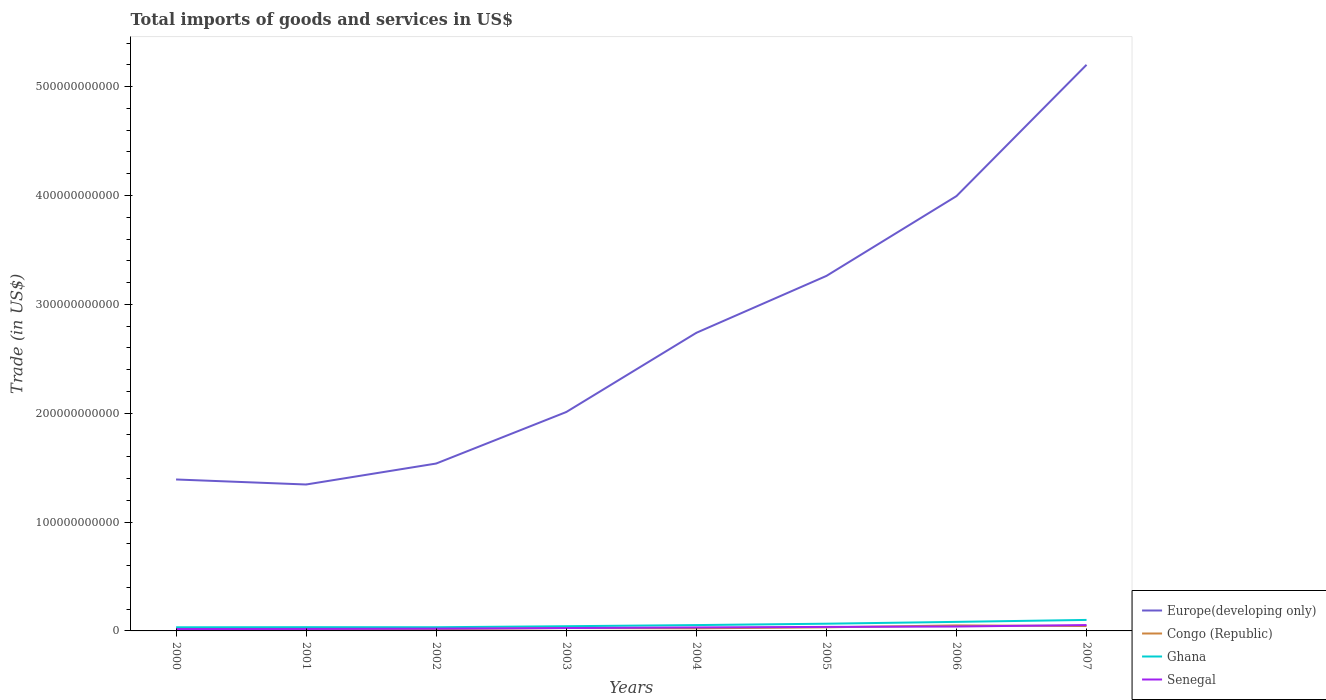Does the line corresponding to Europe(developing only) intersect with the line corresponding to Ghana?
Make the answer very short. No. Across all years, what is the maximum total imports of goods and services in Congo (Republic)?
Make the answer very short. 1.40e+09. In which year was the total imports of goods and services in Congo (Republic) maximum?
Offer a terse response. 2000. What is the total total imports of goods and services in Congo (Republic) in the graph?
Offer a very short reply. -2.41e+09. What is the difference between the highest and the second highest total imports of goods and services in Ghana?
Make the answer very short. 6.76e+09. What is the difference between the highest and the lowest total imports of goods and services in Europe(developing only)?
Offer a very short reply. 4. How many lines are there?
Ensure brevity in your answer.  4. What is the difference between two consecutive major ticks on the Y-axis?
Your response must be concise. 1.00e+11. Does the graph contain grids?
Make the answer very short. No. Where does the legend appear in the graph?
Offer a terse response. Bottom right. How are the legend labels stacked?
Give a very brief answer. Vertical. What is the title of the graph?
Provide a succinct answer. Total imports of goods and services in US$. Does "South Sudan" appear as one of the legend labels in the graph?
Make the answer very short. No. What is the label or title of the Y-axis?
Offer a very short reply. Trade (in US$). What is the Trade (in US$) in Europe(developing only) in 2000?
Offer a very short reply. 1.39e+11. What is the Trade (in US$) in Congo (Republic) in 2000?
Your answer should be compact. 1.40e+09. What is the Trade (in US$) in Ghana in 2000?
Provide a short and direct response. 3.35e+09. What is the Trade (in US$) in Senegal in 2000?
Offer a very short reply. 1.74e+09. What is the Trade (in US$) of Europe(developing only) in 2001?
Your response must be concise. 1.35e+11. What is the Trade (in US$) of Congo (Republic) in 2001?
Offer a terse response. 1.49e+09. What is the Trade (in US$) of Ghana in 2001?
Provide a succinct answer. 3.44e+09. What is the Trade (in US$) of Senegal in 2001?
Give a very brief answer. 1.84e+09. What is the Trade (in US$) of Europe(developing only) in 2002?
Offer a terse response. 1.54e+11. What is the Trade (in US$) in Congo (Republic) in 2002?
Offer a very short reply. 1.63e+09. What is the Trade (in US$) in Ghana in 2002?
Offer a very short reply. 3.38e+09. What is the Trade (in US$) of Senegal in 2002?
Ensure brevity in your answer.  2.08e+09. What is the Trade (in US$) of Europe(developing only) in 2003?
Your answer should be compact. 2.01e+11. What is the Trade (in US$) of Congo (Republic) in 2003?
Provide a short and direct response. 2.66e+09. What is the Trade (in US$) in Ghana in 2003?
Make the answer very short. 4.32e+09. What is the Trade (in US$) of Senegal in 2003?
Keep it short and to the point. 2.66e+09. What is the Trade (in US$) in Europe(developing only) in 2004?
Keep it short and to the point. 2.74e+11. What is the Trade (in US$) in Congo (Republic) in 2004?
Ensure brevity in your answer.  2.36e+09. What is the Trade (in US$) in Ghana in 2004?
Give a very brief answer. 5.36e+09. What is the Trade (in US$) in Senegal in 2004?
Your answer should be very brief. 3.19e+09. What is the Trade (in US$) of Europe(developing only) in 2005?
Ensure brevity in your answer.  3.26e+11. What is the Trade (in US$) of Congo (Republic) in 2005?
Provide a succinct answer. 3.32e+09. What is the Trade (in US$) in Ghana in 2005?
Provide a short and direct response. 6.62e+09. What is the Trade (in US$) in Senegal in 2005?
Your response must be concise. 3.69e+09. What is the Trade (in US$) of Europe(developing only) in 2006?
Your response must be concise. 3.99e+11. What is the Trade (in US$) of Congo (Republic) in 2006?
Your response must be concise. 5.07e+09. What is the Trade (in US$) of Ghana in 2006?
Keep it short and to the point. 8.31e+09. What is the Trade (in US$) of Senegal in 2006?
Provide a succinct answer. 4.03e+09. What is the Trade (in US$) of Europe(developing only) in 2007?
Provide a succinct answer. 5.20e+11. What is the Trade (in US$) of Congo (Republic) in 2007?
Ensure brevity in your answer.  4.49e+09. What is the Trade (in US$) in Ghana in 2007?
Your answer should be very brief. 1.01e+1. What is the Trade (in US$) in Senegal in 2007?
Make the answer very short. 5.40e+09. Across all years, what is the maximum Trade (in US$) in Europe(developing only)?
Keep it short and to the point. 5.20e+11. Across all years, what is the maximum Trade (in US$) in Congo (Republic)?
Give a very brief answer. 5.07e+09. Across all years, what is the maximum Trade (in US$) of Ghana?
Give a very brief answer. 1.01e+1. Across all years, what is the maximum Trade (in US$) of Senegal?
Your answer should be compact. 5.40e+09. Across all years, what is the minimum Trade (in US$) of Europe(developing only)?
Your response must be concise. 1.35e+11. Across all years, what is the minimum Trade (in US$) in Congo (Republic)?
Make the answer very short. 1.40e+09. Across all years, what is the minimum Trade (in US$) in Ghana?
Your answer should be very brief. 3.35e+09. Across all years, what is the minimum Trade (in US$) in Senegal?
Keep it short and to the point. 1.74e+09. What is the total Trade (in US$) of Europe(developing only) in the graph?
Make the answer very short. 2.15e+12. What is the total Trade (in US$) of Congo (Republic) in the graph?
Keep it short and to the point. 2.24e+1. What is the total Trade (in US$) of Ghana in the graph?
Provide a succinct answer. 4.49e+1. What is the total Trade (in US$) in Senegal in the graph?
Your response must be concise. 2.46e+1. What is the difference between the Trade (in US$) of Europe(developing only) in 2000 and that in 2001?
Ensure brevity in your answer.  4.62e+09. What is the difference between the Trade (in US$) of Congo (Republic) in 2000 and that in 2001?
Your answer should be very brief. -8.54e+07. What is the difference between the Trade (in US$) of Ghana in 2000 and that in 2001?
Ensure brevity in your answer.  -9.39e+07. What is the difference between the Trade (in US$) in Senegal in 2000 and that in 2001?
Your response must be concise. -1.00e+08. What is the difference between the Trade (in US$) in Europe(developing only) in 2000 and that in 2002?
Offer a very short reply. -1.47e+1. What is the difference between the Trade (in US$) in Congo (Republic) in 2000 and that in 2002?
Make the answer very short. -2.25e+08. What is the difference between the Trade (in US$) in Ghana in 2000 and that in 2002?
Your answer should be compact. -3.28e+07. What is the difference between the Trade (in US$) of Senegal in 2000 and that in 2002?
Give a very brief answer. -3.37e+08. What is the difference between the Trade (in US$) of Europe(developing only) in 2000 and that in 2003?
Keep it short and to the point. -6.20e+1. What is the difference between the Trade (in US$) of Congo (Republic) in 2000 and that in 2003?
Your response must be concise. -1.25e+09. What is the difference between the Trade (in US$) of Ghana in 2000 and that in 2003?
Make the answer very short. -9.70e+08. What is the difference between the Trade (in US$) of Senegal in 2000 and that in 2003?
Offer a very short reply. -9.15e+08. What is the difference between the Trade (in US$) of Europe(developing only) in 2000 and that in 2004?
Ensure brevity in your answer.  -1.35e+11. What is the difference between the Trade (in US$) of Congo (Republic) in 2000 and that in 2004?
Your response must be concise. -9.59e+08. What is the difference between the Trade (in US$) in Ghana in 2000 and that in 2004?
Provide a short and direct response. -2.01e+09. What is the difference between the Trade (in US$) in Senegal in 2000 and that in 2004?
Your answer should be very brief. -1.45e+09. What is the difference between the Trade (in US$) in Europe(developing only) in 2000 and that in 2005?
Your response must be concise. -1.87e+11. What is the difference between the Trade (in US$) of Congo (Republic) in 2000 and that in 2005?
Give a very brief answer. -1.91e+09. What is the difference between the Trade (in US$) of Ghana in 2000 and that in 2005?
Provide a succinct answer. -3.27e+09. What is the difference between the Trade (in US$) in Senegal in 2000 and that in 2005?
Provide a short and direct response. -1.95e+09. What is the difference between the Trade (in US$) in Europe(developing only) in 2000 and that in 2006?
Provide a short and direct response. -2.60e+11. What is the difference between the Trade (in US$) in Congo (Republic) in 2000 and that in 2006?
Keep it short and to the point. -3.67e+09. What is the difference between the Trade (in US$) in Ghana in 2000 and that in 2006?
Offer a very short reply. -4.96e+09. What is the difference between the Trade (in US$) in Senegal in 2000 and that in 2006?
Make the answer very short. -2.29e+09. What is the difference between the Trade (in US$) of Europe(developing only) in 2000 and that in 2007?
Give a very brief answer. -3.81e+11. What is the difference between the Trade (in US$) of Congo (Republic) in 2000 and that in 2007?
Give a very brief answer. -3.09e+09. What is the difference between the Trade (in US$) in Ghana in 2000 and that in 2007?
Keep it short and to the point. -6.76e+09. What is the difference between the Trade (in US$) of Senegal in 2000 and that in 2007?
Give a very brief answer. -3.66e+09. What is the difference between the Trade (in US$) in Europe(developing only) in 2001 and that in 2002?
Offer a terse response. -1.93e+1. What is the difference between the Trade (in US$) of Congo (Republic) in 2001 and that in 2002?
Your answer should be compact. -1.39e+08. What is the difference between the Trade (in US$) of Ghana in 2001 and that in 2002?
Your answer should be very brief. 6.11e+07. What is the difference between the Trade (in US$) in Senegal in 2001 and that in 2002?
Keep it short and to the point. -2.36e+08. What is the difference between the Trade (in US$) in Europe(developing only) in 2001 and that in 2003?
Your answer should be compact. -6.66e+1. What is the difference between the Trade (in US$) in Congo (Republic) in 2001 and that in 2003?
Keep it short and to the point. -1.17e+09. What is the difference between the Trade (in US$) in Ghana in 2001 and that in 2003?
Your answer should be very brief. -8.76e+08. What is the difference between the Trade (in US$) in Senegal in 2001 and that in 2003?
Provide a succinct answer. -8.15e+08. What is the difference between the Trade (in US$) of Europe(developing only) in 2001 and that in 2004?
Make the answer very short. -1.39e+11. What is the difference between the Trade (in US$) of Congo (Republic) in 2001 and that in 2004?
Offer a terse response. -8.74e+08. What is the difference between the Trade (in US$) of Ghana in 2001 and that in 2004?
Give a very brief answer. -1.92e+09. What is the difference between the Trade (in US$) in Senegal in 2001 and that in 2004?
Make the answer very short. -1.35e+09. What is the difference between the Trade (in US$) of Europe(developing only) in 2001 and that in 2005?
Give a very brief answer. -1.92e+11. What is the difference between the Trade (in US$) of Congo (Republic) in 2001 and that in 2005?
Provide a short and direct response. -1.83e+09. What is the difference between the Trade (in US$) in Ghana in 2001 and that in 2005?
Provide a short and direct response. -3.18e+09. What is the difference between the Trade (in US$) of Senegal in 2001 and that in 2005?
Make the answer very short. -1.85e+09. What is the difference between the Trade (in US$) in Europe(developing only) in 2001 and that in 2006?
Keep it short and to the point. -2.65e+11. What is the difference between the Trade (in US$) in Congo (Republic) in 2001 and that in 2006?
Give a very brief answer. -3.58e+09. What is the difference between the Trade (in US$) in Ghana in 2001 and that in 2006?
Provide a succinct answer. -4.87e+09. What is the difference between the Trade (in US$) of Senegal in 2001 and that in 2006?
Ensure brevity in your answer.  -2.19e+09. What is the difference between the Trade (in US$) of Europe(developing only) in 2001 and that in 2007?
Ensure brevity in your answer.  -3.86e+11. What is the difference between the Trade (in US$) of Congo (Republic) in 2001 and that in 2007?
Offer a very short reply. -3.00e+09. What is the difference between the Trade (in US$) in Ghana in 2001 and that in 2007?
Your answer should be very brief. -6.66e+09. What is the difference between the Trade (in US$) in Senegal in 2001 and that in 2007?
Give a very brief answer. -3.56e+09. What is the difference between the Trade (in US$) of Europe(developing only) in 2002 and that in 2003?
Keep it short and to the point. -4.73e+1. What is the difference between the Trade (in US$) in Congo (Republic) in 2002 and that in 2003?
Your response must be concise. -1.03e+09. What is the difference between the Trade (in US$) in Ghana in 2002 and that in 2003?
Offer a very short reply. -9.37e+08. What is the difference between the Trade (in US$) in Senegal in 2002 and that in 2003?
Ensure brevity in your answer.  -5.79e+08. What is the difference between the Trade (in US$) of Europe(developing only) in 2002 and that in 2004?
Provide a short and direct response. -1.20e+11. What is the difference between the Trade (in US$) in Congo (Republic) in 2002 and that in 2004?
Your answer should be very brief. -7.34e+08. What is the difference between the Trade (in US$) in Ghana in 2002 and that in 2004?
Your answer should be compact. -1.98e+09. What is the difference between the Trade (in US$) in Senegal in 2002 and that in 2004?
Provide a succinct answer. -1.12e+09. What is the difference between the Trade (in US$) in Europe(developing only) in 2002 and that in 2005?
Offer a terse response. -1.72e+11. What is the difference between the Trade (in US$) of Congo (Republic) in 2002 and that in 2005?
Make the answer very short. -1.69e+09. What is the difference between the Trade (in US$) in Ghana in 2002 and that in 2005?
Give a very brief answer. -3.24e+09. What is the difference between the Trade (in US$) in Senegal in 2002 and that in 2005?
Your response must be concise. -1.62e+09. What is the difference between the Trade (in US$) of Europe(developing only) in 2002 and that in 2006?
Keep it short and to the point. -2.46e+11. What is the difference between the Trade (in US$) of Congo (Republic) in 2002 and that in 2006?
Offer a very short reply. -3.44e+09. What is the difference between the Trade (in US$) of Ghana in 2002 and that in 2006?
Make the answer very short. -4.93e+09. What is the difference between the Trade (in US$) in Senegal in 2002 and that in 2006?
Your response must be concise. -1.96e+09. What is the difference between the Trade (in US$) in Europe(developing only) in 2002 and that in 2007?
Keep it short and to the point. -3.66e+11. What is the difference between the Trade (in US$) of Congo (Republic) in 2002 and that in 2007?
Provide a short and direct response. -2.86e+09. What is the difference between the Trade (in US$) of Ghana in 2002 and that in 2007?
Make the answer very short. -6.73e+09. What is the difference between the Trade (in US$) of Senegal in 2002 and that in 2007?
Keep it short and to the point. -3.32e+09. What is the difference between the Trade (in US$) of Europe(developing only) in 2003 and that in 2004?
Your answer should be very brief. -7.28e+1. What is the difference between the Trade (in US$) of Congo (Republic) in 2003 and that in 2004?
Keep it short and to the point. 2.95e+08. What is the difference between the Trade (in US$) of Ghana in 2003 and that in 2004?
Ensure brevity in your answer.  -1.04e+09. What is the difference between the Trade (in US$) in Senegal in 2003 and that in 2004?
Ensure brevity in your answer.  -5.37e+08. What is the difference between the Trade (in US$) of Europe(developing only) in 2003 and that in 2005?
Give a very brief answer. -1.25e+11. What is the difference between the Trade (in US$) in Congo (Republic) in 2003 and that in 2005?
Provide a succinct answer. -6.59e+08. What is the difference between the Trade (in US$) of Ghana in 2003 and that in 2005?
Ensure brevity in your answer.  -2.30e+09. What is the difference between the Trade (in US$) in Senegal in 2003 and that in 2005?
Provide a succinct answer. -1.04e+09. What is the difference between the Trade (in US$) in Europe(developing only) in 2003 and that in 2006?
Give a very brief answer. -1.98e+11. What is the difference between the Trade (in US$) in Congo (Republic) in 2003 and that in 2006?
Offer a very short reply. -2.41e+09. What is the difference between the Trade (in US$) of Ghana in 2003 and that in 2006?
Keep it short and to the point. -3.99e+09. What is the difference between the Trade (in US$) in Senegal in 2003 and that in 2006?
Provide a succinct answer. -1.38e+09. What is the difference between the Trade (in US$) in Europe(developing only) in 2003 and that in 2007?
Ensure brevity in your answer.  -3.19e+11. What is the difference between the Trade (in US$) in Congo (Republic) in 2003 and that in 2007?
Your answer should be very brief. -1.83e+09. What is the difference between the Trade (in US$) of Ghana in 2003 and that in 2007?
Keep it short and to the point. -5.79e+09. What is the difference between the Trade (in US$) of Senegal in 2003 and that in 2007?
Your response must be concise. -2.74e+09. What is the difference between the Trade (in US$) of Europe(developing only) in 2004 and that in 2005?
Offer a terse response. -5.23e+1. What is the difference between the Trade (in US$) in Congo (Republic) in 2004 and that in 2005?
Provide a short and direct response. -9.54e+08. What is the difference between the Trade (in US$) in Ghana in 2004 and that in 2005?
Provide a short and direct response. -1.26e+09. What is the difference between the Trade (in US$) of Senegal in 2004 and that in 2005?
Your answer should be compact. -5.00e+08. What is the difference between the Trade (in US$) in Europe(developing only) in 2004 and that in 2006?
Give a very brief answer. -1.26e+11. What is the difference between the Trade (in US$) of Congo (Republic) in 2004 and that in 2006?
Your answer should be compact. -2.71e+09. What is the difference between the Trade (in US$) of Ghana in 2004 and that in 2006?
Your response must be concise. -2.95e+09. What is the difference between the Trade (in US$) in Senegal in 2004 and that in 2006?
Your response must be concise. -8.39e+08. What is the difference between the Trade (in US$) in Europe(developing only) in 2004 and that in 2007?
Keep it short and to the point. -2.46e+11. What is the difference between the Trade (in US$) in Congo (Republic) in 2004 and that in 2007?
Give a very brief answer. -2.13e+09. What is the difference between the Trade (in US$) of Ghana in 2004 and that in 2007?
Give a very brief answer. -4.75e+09. What is the difference between the Trade (in US$) of Senegal in 2004 and that in 2007?
Make the answer very short. -2.21e+09. What is the difference between the Trade (in US$) of Europe(developing only) in 2005 and that in 2006?
Provide a short and direct response. -7.33e+1. What is the difference between the Trade (in US$) of Congo (Republic) in 2005 and that in 2006?
Offer a very short reply. -1.76e+09. What is the difference between the Trade (in US$) of Ghana in 2005 and that in 2006?
Keep it short and to the point. -1.69e+09. What is the difference between the Trade (in US$) in Senegal in 2005 and that in 2006?
Keep it short and to the point. -3.39e+08. What is the difference between the Trade (in US$) of Europe(developing only) in 2005 and that in 2007?
Provide a succinct answer. -1.94e+11. What is the difference between the Trade (in US$) of Congo (Republic) in 2005 and that in 2007?
Offer a terse response. -1.18e+09. What is the difference between the Trade (in US$) of Ghana in 2005 and that in 2007?
Offer a terse response. -3.49e+09. What is the difference between the Trade (in US$) of Senegal in 2005 and that in 2007?
Your answer should be very brief. -1.71e+09. What is the difference between the Trade (in US$) in Europe(developing only) in 2006 and that in 2007?
Give a very brief answer. -1.21e+11. What is the difference between the Trade (in US$) in Congo (Republic) in 2006 and that in 2007?
Offer a very short reply. 5.80e+08. What is the difference between the Trade (in US$) in Ghana in 2006 and that in 2007?
Ensure brevity in your answer.  -1.80e+09. What is the difference between the Trade (in US$) of Senegal in 2006 and that in 2007?
Ensure brevity in your answer.  -1.37e+09. What is the difference between the Trade (in US$) in Europe(developing only) in 2000 and the Trade (in US$) in Congo (Republic) in 2001?
Offer a terse response. 1.38e+11. What is the difference between the Trade (in US$) of Europe(developing only) in 2000 and the Trade (in US$) of Ghana in 2001?
Offer a terse response. 1.36e+11. What is the difference between the Trade (in US$) in Europe(developing only) in 2000 and the Trade (in US$) in Senegal in 2001?
Your answer should be compact. 1.37e+11. What is the difference between the Trade (in US$) in Congo (Republic) in 2000 and the Trade (in US$) in Ghana in 2001?
Offer a very short reply. -2.04e+09. What is the difference between the Trade (in US$) of Congo (Republic) in 2000 and the Trade (in US$) of Senegal in 2001?
Offer a very short reply. -4.38e+08. What is the difference between the Trade (in US$) of Ghana in 2000 and the Trade (in US$) of Senegal in 2001?
Make the answer very short. 1.51e+09. What is the difference between the Trade (in US$) of Europe(developing only) in 2000 and the Trade (in US$) of Congo (Republic) in 2002?
Your response must be concise. 1.37e+11. What is the difference between the Trade (in US$) in Europe(developing only) in 2000 and the Trade (in US$) in Ghana in 2002?
Your answer should be very brief. 1.36e+11. What is the difference between the Trade (in US$) in Europe(developing only) in 2000 and the Trade (in US$) in Senegal in 2002?
Keep it short and to the point. 1.37e+11. What is the difference between the Trade (in US$) of Congo (Republic) in 2000 and the Trade (in US$) of Ghana in 2002?
Keep it short and to the point. -1.98e+09. What is the difference between the Trade (in US$) of Congo (Republic) in 2000 and the Trade (in US$) of Senegal in 2002?
Provide a short and direct response. -6.74e+08. What is the difference between the Trade (in US$) in Ghana in 2000 and the Trade (in US$) in Senegal in 2002?
Provide a succinct answer. 1.27e+09. What is the difference between the Trade (in US$) of Europe(developing only) in 2000 and the Trade (in US$) of Congo (Republic) in 2003?
Keep it short and to the point. 1.36e+11. What is the difference between the Trade (in US$) in Europe(developing only) in 2000 and the Trade (in US$) in Ghana in 2003?
Make the answer very short. 1.35e+11. What is the difference between the Trade (in US$) of Europe(developing only) in 2000 and the Trade (in US$) of Senegal in 2003?
Offer a very short reply. 1.36e+11. What is the difference between the Trade (in US$) in Congo (Republic) in 2000 and the Trade (in US$) in Ghana in 2003?
Provide a short and direct response. -2.92e+09. What is the difference between the Trade (in US$) of Congo (Republic) in 2000 and the Trade (in US$) of Senegal in 2003?
Keep it short and to the point. -1.25e+09. What is the difference between the Trade (in US$) of Ghana in 2000 and the Trade (in US$) of Senegal in 2003?
Give a very brief answer. 6.94e+08. What is the difference between the Trade (in US$) of Europe(developing only) in 2000 and the Trade (in US$) of Congo (Republic) in 2004?
Your response must be concise. 1.37e+11. What is the difference between the Trade (in US$) of Europe(developing only) in 2000 and the Trade (in US$) of Ghana in 2004?
Offer a very short reply. 1.34e+11. What is the difference between the Trade (in US$) in Europe(developing only) in 2000 and the Trade (in US$) in Senegal in 2004?
Provide a short and direct response. 1.36e+11. What is the difference between the Trade (in US$) in Congo (Republic) in 2000 and the Trade (in US$) in Ghana in 2004?
Ensure brevity in your answer.  -3.96e+09. What is the difference between the Trade (in US$) of Congo (Republic) in 2000 and the Trade (in US$) of Senegal in 2004?
Provide a short and direct response. -1.79e+09. What is the difference between the Trade (in US$) of Ghana in 2000 and the Trade (in US$) of Senegal in 2004?
Your answer should be very brief. 1.57e+08. What is the difference between the Trade (in US$) of Europe(developing only) in 2000 and the Trade (in US$) of Congo (Republic) in 2005?
Provide a short and direct response. 1.36e+11. What is the difference between the Trade (in US$) in Europe(developing only) in 2000 and the Trade (in US$) in Ghana in 2005?
Your response must be concise. 1.32e+11. What is the difference between the Trade (in US$) in Europe(developing only) in 2000 and the Trade (in US$) in Senegal in 2005?
Your answer should be compact. 1.35e+11. What is the difference between the Trade (in US$) in Congo (Republic) in 2000 and the Trade (in US$) in Ghana in 2005?
Keep it short and to the point. -5.22e+09. What is the difference between the Trade (in US$) of Congo (Republic) in 2000 and the Trade (in US$) of Senegal in 2005?
Ensure brevity in your answer.  -2.29e+09. What is the difference between the Trade (in US$) in Ghana in 2000 and the Trade (in US$) in Senegal in 2005?
Your answer should be compact. -3.43e+08. What is the difference between the Trade (in US$) of Europe(developing only) in 2000 and the Trade (in US$) of Congo (Republic) in 2006?
Keep it short and to the point. 1.34e+11. What is the difference between the Trade (in US$) of Europe(developing only) in 2000 and the Trade (in US$) of Ghana in 2006?
Ensure brevity in your answer.  1.31e+11. What is the difference between the Trade (in US$) in Europe(developing only) in 2000 and the Trade (in US$) in Senegal in 2006?
Provide a succinct answer. 1.35e+11. What is the difference between the Trade (in US$) of Congo (Republic) in 2000 and the Trade (in US$) of Ghana in 2006?
Offer a terse response. -6.91e+09. What is the difference between the Trade (in US$) in Congo (Republic) in 2000 and the Trade (in US$) in Senegal in 2006?
Your answer should be compact. -2.63e+09. What is the difference between the Trade (in US$) in Ghana in 2000 and the Trade (in US$) in Senegal in 2006?
Your answer should be compact. -6.82e+08. What is the difference between the Trade (in US$) of Europe(developing only) in 2000 and the Trade (in US$) of Congo (Republic) in 2007?
Offer a terse response. 1.35e+11. What is the difference between the Trade (in US$) in Europe(developing only) in 2000 and the Trade (in US$) in Ghana in 2007?
Ensure brevity in your answer.  1.29e+11. What is the difference between the Trade (in US$) in Europe(developing only) in 2000 and the Trade (in US$) in Senegal in 2007?
Provide a short and direct response. 1.34e+11. What is the difference between the Trade (in US$) in Congo (Republic) in 2000 and the Trade (in US$) in Ghana in 2007?
Provide a succinct answer. -8.70e+09. What is the difference between the Trade (in US$) of Congo (Republic) in 2000 and the Trade (in US$) of Senegal in 2007?
Offer a very short reply. -3.99e+09. What is the difference between the Trade (in US$) in Ghana in 2000 and the Trade (in US$) in Senegal in 2007?
Your answer should be very brief. -2.05e+09. What is the difference between the Trade (in US$) in Europe(developing only) in 2001 and the Trade (in US$) in Congo (Republic) in 2002?
Your answer should be compact. 1.33e+11. What is the difference between the Trade (in US$) of Europe(developing only) in 2001 and the Trade (in US$) of Ghana in 2002?
Make the answer very short. 1.31e+11. What is the difference between the Trade (in US$) in Europe(developing only) in 2001 and the Trade (in US$) in Senegal in 2002?
Give a very brief answer. 1.32e+11. What is the difference between the Trade (in US$) of Congo (Republic) in 2001 and the Trade (in US$) of Ghana in 2002?
Your answer should be very brief. -1.89e+09. What is the difference between the Trade (in US$) in Congo (Republic) in 2001 and the Trade (in US$) in Senegal in 2002?
Offer a terse response. -5.89e+08. What is the difference between the Trade (in US$) of Ghana in 2001 and the Trade (in US$) of Senegal in 2002?
Offer a very short reply. 1.37e+09. What is the difference between the Trade (in US$) in Europe(developing only) in 2001 and the Trade (in US$) in Congo (Republic) in 2003?
Provide a succinct answer. 1.32e+11. What is the difference between the Trade (in US$) of Europe(developing only) in 2001 and the Trade (in US$) of Ghana in 2003?
Your answer should be very brief. 1.30e+11. What is the difference between the Trade (in US$) in Europe(developing only) in 2001 and the Trade (in US$) in Senegal in 2003?
Your answer should be compact. 1.32e+11. What is the difference between the Trade (in US$) in Congo (Republic) in 2001 and the Trade (in US$) in Ghana in 2003?
Your answer should be very brief. -2.83e+09. What is the difference between the Trade (in US$) in Congo (Republic) in 2001 and the Trade (in US$) in Senegal in 2003?
Provide a succinct answer. -1.17e+09. What is the difference between the Trade (in US$) in Ghana in 2001 and the Trade (in US$) in Senegal in 2003?
Give a very brief answer. 7.88e+08. What is the difference between the Trade (in US$) of Europe(developing only) in 2001 and the Trade (in US$) of Congo (Republic) in 2004?
Your answer should be compact. 1.32e+11. What is the difference between the Trade (in US$) of Europe(developing only) in 2001 and the Trade (in US$) of Ghana in 2004?
Ensure brevity in your answer.  1.29e+11. What is the difference between the Trade (in US$) in Europe(developing only) in 2001 and the Trade (in US$) in Senegal in 2004?
Make the answer very short. 1.31e+11. What is the difference between the Trade (in US$) in Congo (Republic) in 2001 and the Trade (in US$) in Ghana in 2004?
Ensure brevity in your answer.  -3.87e+09. What is the difference between the Trade (in US$) of Congo (Republic) in 2001 and the Trade (in US$) of Senegal in 2004?
Give a very brief answer. -1.70e+09. What is the difference between the Trade (in US$) of Ghana in 2001 and the Trade (in US$) of Senegal in 2004?
Keep it short and to the point. 2.51e+08. What is the difference between the Trade (in US$) in Europe(developing only) in 2001 and the Trade (in US$) in Congo (Republic) in 2005?
Your answer should be very brief. 1.31e+11. What is the difference between the Trade (in US$) of Europe(developing only) in 2001 and the Trade (in US$) of Ghana in 2005?
Offer a very short reply. 1.28e+11. What is the difference between the Trade (in US$) of Europe(developing only) in 2001 and the Trade (in US$) of Senegal in 2005?
Your answer should be very brief. 1.31e+11. What is the difference between the Trade (in US$) in Congo (Republic) in 2001 and the Trade (in US$) in Ghana in 2005?
Keep it short and to the point. -5.13e+09. What is the difference between the Trade (in US$) of Congo (Republic) in 2001 and the Trade (in US$) of Senegal in 2005?
Make the answer very short. -2.20e+09. What is the difference between the Trade (in US$) in Ghana in 2001 and the Trade (in US$) in Senegal in 2005?
Offer a terse response. -2.49e+08. What is the difference between the Trade (in US$) of Europe(developing only) in 2001 and the Trade (in US$) of Congo (Republic) in 2006?
Offer a terse response. 1.29e+11. What is the difference between the Trade (in US$) of Europe(developing only) in 2001 and the Trade (in US$) of Ghana in 2006?
Offer a very short reply. 1.26e+11. What is the difference between the Trade (in US$) in Europe(developing only) in 2001 and the Trade (in US$) in Senegal in 2006?
Your answer should be compact. 1.30e+11. What is the difference between the Trade (in US$) of Congo (Republic) in 2001 and the Trade (in US$) of Ghana in 2006?
Offer a terse response. -6.82e+09. What is the difference between the Trade (in US$) of Congo (Republic) in 2001 and the Trade (in US$) of Senegal in 2006?
Offer a very short reply. -2.54e+09. What is the difference between the Trade (in US$) in Ghana in 2001 and the Trade (in US$) in Senegal in 2006?
Give a very brief answer. -5.89e+08. What is the difference between the Trade (in US$) of Europe(developing only) in 2001 and the Trade (in US$) of Congo (Republic) in 2007?
Give a very brief answer. 1.30e+11. What is the difference between the Trade (in US$) of Europe(developing only) in 2001 and the Trade (in US$) of Ghana in 2007?
Provide a succinct answer. 1.24e+11. What is the difference between the Trade (in US$) in Europe(developing only) in 2001 and the Trade (in US$) in Senegal in 2007?
Provide a short and direct response. 1.29e+11. What is the difference between the Trade (in US$) of Congo (Republic) in 2001 and the Trade (in US$) of Ghana in 2007?
Provide a short and direct response. -8.62e+09. What is the difference between the Trade (in US$) of Congo (Republic) in 2001 and the Trade (in US$) of Senegal in 2007?
Offer a very short reply. -3.91e+09. What is the difference between the Trade (in US$) of Ghana in 2001 and the Trade (in US$) of Senegal in 2007?
Provide a succinct answer. -1.95e+09. What is the difference between the Trade (in US$) in Europe(developing only) in 2002 and the Trade (in US$) in Congo (Republic) in 2003?
Provide a succinct answer. 1.51e+11. What is the difference between the Trade (in US$) of Europe(developing only) in 2002 and the Trade (in US$) of Ghana in 2003?
Your answer should be compact. 1.49e+11. What is the difference between the Trade (in US$) of Europe(developing only) in 2002 and the Trade (in US$) of Senegal in 2003?
Provide a short and direct response. 1.51e+11. What is the difference between the Trade (in US$) of Congo (Republic) in 2002 and the Trade (in US$) of Ghana in 2003?
Provide a short and direct response. -2.69e+09. What is the difference between the Trade (in US$) in Congo (Republic) in 2002 and the Trade (in US$) in Senegal in 2003?
Give a very brief answer. -1.03e+09. What is the difference between the Trade (in US$) in Ghana in 2002 and the Trade (in US$) in Senegal in 2003?
Your answer should be very brief. 7.27e+08. What is the difference between the Trade (in US$) in Europe(developing only) in 2002 and the Trade (in US$) in Congo (Republic) in 2004?
Your answer should be very brief. 1.51e+11. What is the difference between the Trade (in US$) in Europe(developing only) in 2002 and the Trade (in US$) in Ghana in 2004?
Keep it short and to the point. 1.48e+11. What is the difference between the Trade (in US$) in Europe(developing only) in 2002 and the Trade (in US$) in Senegal in 2004?
Offer a very short reply. 1.51e+11. What is the difference between the Trade (in US$) in Congo (Republic) in 2002 and the Trade (in US$) in Ghana in 2004?
Ensure brevity in your answer.  -3.73e+09. What is the difference between the Trade (in US$) of Congo (Republic) in 2002 and the Trade (in US$) of Senegal in 2004?
Offer a terse response. -1.56e+09. What is the difference between the Trade (in US$) in Ghana in 2002 and the Trade (in US$) in Senegal in 2004?
Ensure brevity in your answer.  1.90e+08. What is the difference between the Trade (in US$) in Europe(developing only) in 2002 and the Trade (in US$) in Congo (Republic) in 2005?
Keep it short and to the point. 1.50e+11. What is the difference between the Trade (in US$) in Europe(developing only) in 2002 and the Trade (in US$) in Ghana in 2005?
Offer a terse response. 1.47e+11. What is the difference between the Trade (in US$) of Europe(developing only) in 2002 and the Trade (in US$) of Senegal in 2005?
Your answer should be very brief. 1.50e+11. What is the difference between the Trade (in US$) in Congo (Republic) in 2002 and the Trade (in US$) in Ghana in 2005?
Your answer should be very brief. -4.99e+09. What is the difference between the Trade (in US$) in Congo (Republic) in 2002 and the Trade (in US$) in Senegal in 2005?
Offer a very short reply. -2.06e+09. What is the difference between the Trade (in US$) in Ghana in 2002 and the Trade (in US$) in Senegal in 2005?
Provide a short and direct response. -3.10e+08. What is the difference between the Trade (in US$) of Europe(developing only) in 2002 and the Trade (in US$) of Congo (Republic) in 2006?
Keep it short and to the point. 1.49e+11. What is the difference between the Trade (in US$) in Europe(developing only) in 2002 and the Trade (in US$) in Ghana in 2006?
Your response must be concise. 1.45e+11. What is the difference between the Trade (in US$) in Europe(developing only) in 2002 and the Trade (in US$) in Senegal in 2006?
Your response must be concise. 1.50e+11. What is the difference between the Trade (in US$) of Congo (Republic) in 2002 and the Trade (in US$) of Ghana in 2006?
Give a very brief answer. -6.68e+09. What is the difference between the Trade (in US$) of Congo (Republic) in 2002 and the Trade (in US$) of Senegal in 2006?
Keep it short and to the point. -2.40e+09. What is the difference between the Trade (in US$) of Ghana in 2002 and the Trade (in US$) of Senegal in 2006?
Give a very brief answer. -6.50e+08. What is the difference between the Trade (in US$) in Europe(developing only) in 2002 and the Trade (in US$) in Congo (Republic) in 2007?
Provide a succinct answer. 1.49e+11. What is the difference between the Trade (in US$) in Europe(developing only) in 2002 and the Trade (in US$) in Ghana in 2007?
Your answer should be compact. 1.44e+11. What is the difference between the Trade (in US$) in Europe(developing only) in 2002 and the Trade (in US$) in Senegal in 2007?
Give a very brief answer. 1.48e+11. What is the difference between the Trade (in US$) in Congo (Republic) in 2002 and the Trade (in US$) in Ghana in 2007?
Your response must be concise. -8.48e+09. What is the difference between the Trade (in US$) in Congo (Republic) in 2002 and the Trade (in US$) in Senegal in 2007?
Offer a terse response. -3.77e+09. What is the difference between the Trade (in US$) in Ghana in 2002 and the Trade (in US$) in Senegal in 2007?
Your answer should be compact. -2.02e+09. What is the difference between the Trade (in US$) of Europe(developing only) in 2003 and the Trade (in US$) of Congo (Republic) in 2004?
Your response must be concise. 1.99e+11. What is the difference between the Trade (in US$) in Europe(developing only) in 2003 and the Trade (in US$) in Ghana in 2004?
Offer a very short reply. 1.96e+11. What is the difference between the Trade (in US$) in Europe(developing only) in 2003 and the Trade (in US$) in Senegal in 2004?
Offer a very short reply. 1.98e+11. What is the difference between the Trade (in US$) of Congo (Republic) in 2003 and the Trade (in US$) of Ghana in 2004?
Offer a terse response. -2.70e+09. What is the difference between the Trade (in US$) in Congo (Republic) in 2003 and the Trade (in US$) in Senegal in 2004?
Give a very brief answer. -5.35e+08. What is the difference between the Trade (in US$) of Ghana in 2003 and the Trade (in US$) of Senegal in 2004?
Your response must be concise. 1.13e+09. What is the difference between the Trade (in US$) of Europe(developing only) in 2003 and the Trade (in US$) of Congo (Republic) in 2005?
Offer a terse response. 1.98e+11. What is the difference between the Trade (in US$) of Europe(developing only) in 2003 and the Trade (in US$) of Ghana in 2005?
Your answer should be very brief. 1.94e+11. What is the difference between the Trade (in US$) of Europe(developing only) in 2003 and the Trade (in US$) of Senegal in 2005?
Your answer should be compact. 1.97e+11. What is the difference between the Trade (in US$) of Congo (Republic) in 2003 and the Trade (in US$) of Ghana in 2005?
Your response must be concise. -3.97e+09. What is the difference between the Trade (in US$) in Congo (Republic) in 2003 and the Trade (in US$) in Senegal in 2005?
Give a very brief answer. -1.04e+09. What is the difference between the Trade (in US$) of Ghana in 2003 and the Trade (in US$) of Senegal in 2005?
Keep it short and to the point. 6.27e+08. What is the difference between the Trade (in US$) in Europe(developing only) in 2003 and the Trade (in US$) in Congo (Republic) in 2006?
Offer a very short reply. 1.96e+11. What is the difference between the Trade (in US$) of Europe(developing only) in 2003 and the Trade (in US$) of Ghana in 2006?
Offer a terse response. 1.93e+11. What is the difference between the Trade (in US$) of Europe(developing only) in 2003 and the Trade (in US$) of Senegal in 2006?
Your answer should be compact. 1.97e+11. What is the difference between the Trade (in US$) of Congo (Republic) in 2003 and the Trade (in US$) of Ghana in 2006?
Your answer should be very brief. -5.65e+09. What is the difference between the Trade (in US$) in Congo (Republic) in 2003 and the Trade (in US$) in Senegal in 2006?
Your answer should be compact. -1.37e+09. What is the difference between the Trade (in US$) in Ghana in 2003 and the Trade (in US$) in Senegal in 2006?
Your response must be concise. 2.87e+08. What is the difference between the Trade (in US$) in Europe(developing only) in 2003 and the Trade (in US$) in Congo (Republic) in 2007?
Your response must be concise. 1.97e+11. What is the difference between the Trade (in US$) of Europe(developing only) in 2003 and the Trade (in US$) of Ghana in 2007?
Give a very brief answer. 1.91e+11. What is the difference between the Trade (in US$) in Europe(developing only) in 2003 and the Trade (in US$) in Senegal in 2007?
Make the answer very short. 1.96e+11. What is the difference between the Trade (in US$) in Congo (Republic) in 2003 and the Trade (in US$) in Ghana in 2007?
Your answer should be very brief. -7.45e+09. What is the difference between the Trade (in US$) in Congo (Republic) in 2003 and the Trade (in US$) in Senegal in 2007?
Your response must be concise. -2.74e+09. What is the difference between the Trade (in US$) in Ghana in 2003 and the Trade (in US$) in Senegal in 2007?
Provide a short and direct response. -1.08e+09. What is the difference between the Trade (in US$) in Europe(developing only) in 2004 and the Trade (in US$) in Congo (Republic) in 2005?
Provide a short and direct response. 2.71e+11. What is the difference between the Trade (in US$) of Europe(developing only) in 2004 and the Trade (in US$) of Ghana in 2005?
Give a very brief answer. 2.67e+11. What is the difference between the Trade (in US$) in Europe(developing only) in 2004 and the Trade (in US$) in Senegal in 2005?
Your response must be concise. 2.70e+11. What is the difference between the Trade (in US$) in Congo (Republic) in 2004 and the Trade (in US$) in Ghana in 2005?
Offer a very short reply. -4.26e+09. What is the difference between the Trade (in US$) in Congo (Republic) in 2004 and the Trade (in US$) in Senegal in 2005?
Ensure brevity in your answer.  -1.33e+09. What is the difference between the Trade (in US$) in Ghana in 2004 and the Trade (in US$) in Senegal in 2005?
Your answer should be compact. 1.67e+09. What is the difference between the Trade (in US$) in Europe(developing only) in 2004 and the Trade (in US$) in Congo (Republic) in 2006?
Your answer should be very brief. 2.69e+11. What is the difference between the Trade (in US$) in Europe(developing only) in 2004 and the Trade (in US$) in Ghana in 2006?
Provide a succinct answer. 2.66e+11. What is the difference between the Trade (in US$) in Europe(developing only) in 2004 and the Trade (in US$) in Senegal in 2006?
Provide a short and direct response. 2.70e+11. What is the difference between the Trade (in US$) in Congo (Republic) in 2004 and the Trade (in US$) in Ghana in 2006?
Your answer should be compact. -5.95e+09. What is the difference between the Trade (in US$) of Congo (Republic) in 2004 and the Trade (in US$) of Senegal in 2006?
Your answer should be very brief. -1.67e+09. What is the difference between the Trade (in US$) of Ghana in 2004 and the Trade (in US$) of Senegal in 2006?
Keep it short and to the point. 1.33e+09. What is the difference between the Trade (in US$) in Europe(developing only) in 2004 and the Trade (in US$) in Congo (Republic) in 2007?
Provide a short and direct response. 2.69e+11. What is the difference between the Trade (in US$) in Europe(developing only) in 2004 and the Trade (in US$) in Ghana in 2007?
Ensure brevity in your answer.  2.64e+11. What is the difference between the Trade (in US$) in Europe(developing only) in 2004 and the Trade (in US$) in Senegal in 2007?
Ensure brevity in your answer.  2.68e+11. What is the difference between the Trade (in US$) in Congo (Republic) in 2004 and the Trade (in US$) in Ghana in 2007?
Ensure brevity in your answer.  -7.75e+09. What is the difference between the Trade (in US$) in Congo (Republic) in 2004 and the Trade (in US$) in Senegal in 2007?
Offer a very short reply. -3.04e+09. What is the difference between the Trade (in US$) of Ghana in 2004 and the Trade (in US$) of Senegal in 2007?
Offer a terse response. -3.77e+07. What is the difference between the Trade (in US$) in Europe(developing only) in 2005 and the Trade (in US$) in Congo (Republic) in 2006?
Offer a very short reply. 3.21e+11. What is the difference between the Trade (in US$) of Europe(developing only) in 2005 and the Trade (in US$) of Ghana in 2006?
Provide a short and direct response. 3.18e+11. What is the difference between the Trade (in US$) of Europe(developing only) in 2005 and the Trade (in US$) of Senegal in 2006?
Ensure brevity in your answer.  3.22e+11. What is the difference between the Trade (in US$) in Congo (Republic) in 2005 and the Trade (in US$) in Ghana in 2006?
Keep it short and to the point. -4.99e+09. What is the difference between the Trade (in US$) of Congo (Republic) in 2005 and the Trade (in US$) of Senegal in 2006?
Make the answer very short. -7.16e+08. What is the difference between the Trade (in US$) of Ghana in 2005 and the Trade (in US$) of Senegal in 2006?
Your answer should be very brief. 2.59e+09. What is the difference between the Trade (in US$) of Europe(developing only) in 2005 and the Trade (in US$) of Congo (Republic) in 2007?
Your answer should be compact. 3.22e+11. What is the difference between the Trade (in US$) in Europe(developing only) in 2005 and the Trade (in US$) in Ghana in 2007?
Make the answer very short. 3.16e+11. What is the difference between the Trade (in US$) in Europe(developing only) in 2005 and the Trade (in US$) in Senegal in 2007?
Keep it short and to the point. 3.21e+11. What is the difference between the Trade (in US$) in Congo (Republic) in 2005 and the Trade (in US$) in Ghana in 2007?
Make the answer very short. -6.79e+09. What is the difference between the Trade (in US$) in Congo (Republic) in 2005 and the Trade (in US$) in Senegal in 2007?
Keep it short and to the point. -2.08e+09. What is the difference between the Trade (in US$) of Ghana in 2005 and the Trade (in US$) of Senegal in 2007?
Your response must be concise. 1.22e+09. What is the difference between the Trade (in US$) of Europe(developing only) in 2006 and the Trade (in US$) of Congo (Republic) in 2007?
Keep it short and to the point. 3.95e+11. What is the difference between the Trade (in US$) of Europe(developing only) in 2006 and the Trade (in US$) of Ghana in 2007?
Your answer should be compact. 3.89e+11. What is the difference between the Trade (in US$) in Europe(developing only) in 2006 and the Trade (in US$) in Senegal in 2007?
Ensure brevity in your answer.  3.94e+11. What is the difference between the Trade (in US$) of Congo (Republic) in 2006 and the Trade (in US$) of Ghana in 2007?
Offer a terse response. -5.04e+09. What is the difference between the Trade (in US$) of Congo (Republic) in 2006 and the Trade (in US$) of Senegal in 2007?
Provide a short and direct response. -3.26e+08. What is the difference between the Trade (in US$) in Ghana in 2006 and the Trade (in US$) in Senegal in 2007?
Your answer should be compact. 2.91e+09. What is the average Trade (in US$) in Europe(developing only) per year?
Keep it short and to the point. 2.68e+11. What is the average Trade (in US$) of Congo (Republic) per year?
Make the answer very short. 2.80e+09. What is the average Trade (in US$) in Ghana per year?
Provide a succinct answer. 5.61e+09. What is the average Trade (in US$) in Senegal per year?
Offer a very short reply. 3.08e+09. In the year 2000, what is the difference between the Trade (in US$) of Europe(developing only) and Trade (in US$) of Congo (Republic)?
Give a very brief answer. 1.38e+11. In the year 2000, what is the difference between the Trade (in US$) in Europe(developing only) and Trade (in US$) in Ghana?
Give a very brief answer. 1.36e+11. In the year 2000, what is the difference between the Trade (in US$) in Europe(developing only) and Trade (in US$) in Senegal?
Offer a terse response. 1.37e+11. In the year 2000, what is the difference between the Trade (in US$) of Congo (Republic) and Trade (in US$) of Ghana?
Provide a short and direct response. -1.95e+09. In the year 2000, what is the difference between the Trade (in US$) of Congo (Republic) and Trade (in US$) of Senegal?
Make the answer very short. -3.37e+08. In the year 2000, what is the difference between the Trade (in US$) in Ghana and Trade (in US$) in Senegal?
Provide a succinct answer. 1.61e+09. In the year 2001, what is the difference between the Trade (in US$) of Europe(developing only) and Trade (in US$) of Congo (Republic)?
Keep it short and to the point. 1.33e+11. In the year 2001, what is the difference between the Trade (in US$) of Europe(developing only) and Trade (in US$) of Ghana?
Your answer should be compact. 1.31e+11. In the year 2001, what is the difference between the Trade (in US$) of Europe(developing only) and Trade (in US$) of Senegal?
Offer a terse response. 1.33e+11. In the year 2001, what is the difference between the Trade (in US$) of Congo (Republic) and Trade (in US$) of Ghana?
Offer a terse response. -1.96e+09. In the year 2001, what is the difference between the Trade (in US$) of Congo (Republic) and Trade (in US$) of Senegal?
Keep it short and to the point. -3.52e+08. In the year 2001, what is the difference between the Trade (in US$) in Ghana and Trade (in US$) in Senegal?
Your answer should be very brief. 1.60e+09. In the year 2002, what is the difference between the Trade (in US$) in Europe(developing only) and Trade (in US$) in Congo (Republic)?
Your answer should be very brief. 1.52e+11. In the year 2002, what is the difference between the Trade (in US$) in Europe(developing only) and Trade (in US$) in Ghana?
Your answer should be compact. 1.50e+11. In the year 2002, what is the difference between the Trade (in US$) in Europe(developing only) and Trade (in US$) in Senegal?
Offer a very short reply. 1.52e+11. In the year 2002, what is the difference between the Trade (in US$) of Congo (Republic) and Trade (in US$) of Ghana?
Provide a succinct answer. -1.75e+09. In the year 2002, what is the difference between the Trade (in US$) of Congo (Republic) and Trade (in US$) of Senegal?
Your answer should be very brief. -4.49e+08. In the year 2002, what is the difference between the Trade (in US$) of Ghana and Trade (in US$) of Senegal?
Your answer should be very brief. 1.31e+09. In the year 2003, what is the difference between the Trade (in US$) in Europe(developing only) and Trade (in US$) in Congo (Republic)?
Keep it short and to the point. 1.98e+11. In the year 2003, what is the difference between the Trade (in US$) in Europe(developing only) and Trade (in US$) in Ghana?
Provide a short and direct response. 1.97e+11. In the year 2003, what is the difference between the Trade (in US$) in Europe(developing only) and Trade (in US$) in Senegal?
Your answer should be compact. 1.98e+11. In the year 2003, what is the difference between the Trade (in US$) of Congo (Republic) and Trade (in US$) of Ghana?
Provide a succinct answer. -1.66e+09. In the year 2003, what is the difference between the Trade (in US$) of Congo (Republic) and Trade (in US$) of Senegal?
Provide a short and direct response. 1.67e+06. In the year 2003, what is the difference between the Trade (in US$) in Ghana and Trade (in US$) in Senegal?
Ensure brevity in your answer.  1.66e+09. In the year 2004, what is the difference between the Trade (in US$) in Europe(developing only) and Trade (in US$) in Congo (Republic)?
Provide a succinct answer. 2.71e+11. In the year 2004, what is the difference between the Trade (in US$) of Europe(developing only) and Trade (in US$) of Ghana?
Your answer should be compact. 2.68e+11. In the year 2004, what is the difference between the Trade (in US$) in Europe(developing only) and Trade (in US$) in Senegal?
Offer a terse response. 2.71e+11. In the year 2004, what is the difference between the Trade (in US$) in Congo (Republic) and Trade (in US$) in Ghana?
Keep it short and to the point. -3.00e+09. In the year 2004, what is the difference between the Trade (in US$) in Congo (Republic) and Trade (in US$) in Senegal?
Keep it short and to the point. -8.31e+08. In the year 2004, what is the difference between the Trade (in US$) of Ghana and Trade (in US$) of Senegal?
Offer a terse response. 2.17e+09. In the year 2005, what is the difference between the Trade (in US$) of Europe(developing only) and Trade (in US$) of Congo (Republic)?
Provide a short and direct response. 3.23e+11. In the year 2005, what is the difference between the Trade (in US$) of Europe(developing only) and Trade (in US$) of Ghana?
Your answer should be compact. 3.19e+11. In the year 2005, what is the difference between the Trade (in US$) of Europe(developing only) and Trade (in US$) of Senegal?
Keep it short and to the point. 3.22e+11. In the year 2005, what is the difference between the Trade (in US$) of Congo (Republic) and Trade (in US$) of Ghana?
Offer a very short reply. -3.31e+09. In the year 2005, what is the difference between the Trade (in US$) of Congo (Republic) and Trade (in US$) of Senegal?
Your answer should be compact. -3.76e+08. In the year 2005, what is the difference between the Trade (in US$) in Ghana and Trade (in US$) in Senegal?
Your answer should be very brief. 2.93e+09. In the year 2006, what is the difference between the Trade (in US$) in Europe(developing only) and Trade (in US$) in Congo (Republic)?
Provide a succinct answer. 3.94e+11. In the year 2006, what is the difference between the Trade (in US$) of Europe(developing only) and Trade (in US$) of Ghana?
Your answer should be very brief. 3.91e+11. In the year 2006, what is the difference between the Trade (in US$) in Europe(developing only) and Trade (in US$) in Senegal?
Offer a very short reply. 3.95e+11. In the year 2006, what is the difference between the Trade (in US$) of Congo (Republic) and Trade (in US$) of Ghana?
Your answer should be very brief. -3.24e+09. In the year 2006, what is the difference between the Trade (in US$) of Congo (Republic) and Trade (in US$) of Senegal?
Your answer should be compact. 1.04e+09. In the year 2006, what is the difference between the Trade (in US$) of Ghana and Trade (in US$) of Senegal?
Provide a short and direct response. 4.28e+09. In the year 2007, what is the difference between the Trade (in US$) of Europe(developing only) and Trade (in US$) of Congo (Republic)?
Give a very brief answer. 5.16e+11. In the year 2007, what is the difference between the Trade (in US$) of Europe(developing only) and Trade (in US$) of Ghana?
Give a very brief answer. 5.10e+11. In the year 2007, what is the difference between the Trade (in US$) of Europe(developing only) and Trade (in US$) of Senegal?
Ensure brevity in your answer.  5.15e+11. In the year 2007, what is the difference between the Trade (in US$) of Congo (Republic) and Trade (in US$) of Ghana?
Give a very brief answer. -5.62e+09. In the year 2007, what is the difference between the Trade (in US$) in Congo (Republic) and Trade (in US$) in Senegal?
Provide a succinct answer. -9.06e+08. In the year 2007, what is the difference between the Trade (in US$) in Ghana and Trade (in US$) in Senegal?
Provide a short and direct response. 4.71e+09. What is the ratio of the Trade (in US$) of Europe(developing only) in 2000 to that in 2001?
Provide a succinct answer. 1.03. What is the ratio of the Trade (in US$) of Congo (Republic) in 2000 to that in 2001?
Ensure brevity in your answer.  0.94. What is the ratio of the Trade (in US$) in Ghana in 2000 to that in 2001?
Provide a short and direct response. 0.97. What is the ratio of the Trade (in US$) in Senegal in 2000 to that in 2001?
Ensure brevity in your answer.  0.95. What is the ratio of the Trade (in US$) in Europe(developing only) in 2000 to that in 2002?
Make the answer very short. 0.9. What is the ratio of the Trade (in US$) in Congo (Republic) in 2000 to that in 2002?
Offer a very short reply. 0.86. What is the ratio of the Trade (in US$) of Ghana in 2000 to that in 2002?
Your answer should be compact. 0.99. What is the ratio of the Trade (in US$) of Senegal in 2000 to that in 2002?
Provide a short and direct response. 0.84. What is the ratio of the Trade (in US$) in Europe(developing only) in 2000 to that in 2003?
Offer a terse response. 0.69. What is the ratio of the Trade (in US$) of Congo (Republic) in 2000 to that in 2003?
Provide a short and direct response. 0.53. What is the ratio of the Trade (in US$) of Ghana in 2000 to that in 2003?
Provide a succinct answer. 0.78. What is the ratio of the Trade (in US$) in Senegal in 2000 to that in 2003?
Provide a succinct answer. 0.66. What is the ratio of the Trade (in US$) of Europe(developing only) in 2000 to that in 2004?
Your response must be concise. 0.51. What is the ratio of the Trade (in US$) in Congo (Republic) in 2000 to that in 2004?
Your answer should be compact. 0.59. What is the ratio of the Trade (in US$) in Senegal in 2000 to that in 2004?
Offer a very short reply. 0.55. What is the ratio of the Trade (in US$) in Europe(developing only) in 2000 to that in 2005?
Offer a very short reply. 0.43. What is the ratio of the Trade (in US$) of Congo (Republic) in 2000 to that in 2005?
Give a very brief answer. 0.42. What is the ratio of the Trade (in US$) of Ghana in 2000 to that in 2005?
Keep it short and to the point. 0.51. What is the ratio of the Trade (in US$) in Senegal in 2000 to that in 2005?
Make the answer very short. 0.47. What is the ratio of the Trade (in US$) of Europe(developing only) in 2000 to that in 2006?
Give a very brief answer. 0.35. What is the ratio of the Trade (in US$) in Congo (Republic) in 2000 to that in 2006?
Provide a succinct answer. 0.28. What is the ratio of the Trade (in US$) in Ghana in 2000 to that in 2006?
Your response must be concise. 0.4. What is the ratio of the Trade (in US$) in Senegal in 2000 to that in 2006?
Keep it short and to the point. 0.43. What is the ratio of the Trade (in US$) in Europe(developing only) in 2000 to that in 2007?
Provide a succinct answer. 0.27. What is the ratio of the Trade (in US$) of Congo (Republic) in 2000 to that in 2007?
Make the answer very short. 0.31. What is the ratio of the Trade (in US$) of Ghana in 2000 to that in 2007?
Make the answer very short. 0.33. What is the ratio of the Trade (in US$) of Senegal in 2000 to that in 2007?
Keep it short and to the point. 0.32. What is the ratio of the Trade (in US$) of Europe(developing only) in 2001 to that in 2002?
Make the answer very short. 0.87. What is the ratio of the Trade (in US$) in Congo (Republic) in 2001 to that in 2002?
Your answer should be compact. 0.91. What is the ratio of the Trade (in US$) in Ghana in 2001 to that in 2002?
Your answer should be very brief. 1.02. What is the ratio of the Trade (in US$) in Senegal in 2001 to that in 2002?
Your answer should be very brief. 0.89. What is the ratio of the Trade (in US$) of Europe(developing only) in 2001 to that in 2003?
Your answer should be compact. 0.67. What is the ratio of the Trade (in US$) of Congo (Republic) in 2001 to that in 2003?
Your answer should be very brief. 0.56. What is the ratio of the Trade (in US$) of Ghana in 2001 to that in 2003?
Keep it short and to the point. 0.8. What is the ratio of the Trade (in US$) in Senegal in 2001 to that in 2003?
Offer a very short reply. 0.69. What is the ratio of the Trade (in US$) of Europe(developing only) in 2001 to that in 2004?
Your response must be concise. 0.49. What is the ratio of the Trade (in US$) of Congo (Republic) in 2001 to that in 2004?
Offer a very short reply. 0.63. What is the ratio of the Trade (in US$) in Ghana in 2001 to that in 2004?
Make the answer very short. 0.64. What is the ratio of the Trade (in US$) of Senegal in 2001 to that in 2004?
Give a very brief answer. 0.58. What is the ratio of the Trade (in US$) in Europe(developing only) in 2001 to that in 2005?
Ensure brevity in your answer.  0.41. What is the ratio of the Trade (in US$) in Congo (Republic) in 2001 to that in 2005?
Make the answer very short. 0.45. What is the ratio of the Trade (in US$) of Ghana in 2001 to that in 2005?
Give a very brief answer. 0.52. What is the ratio of the Trade (in US$) of Senegal in 2001 to that in 2005?
Make the answer very short. 0.5. What is the ratio of the Trade (in US$) in Europe(developing only) in 2001 to that in 2006?
Give a very brief answer. 0.34. What is the ratio of the Trade (in US$) in Congo (Republic) in 2001 to that in 2006?
Your answer should be compact. 0.29. What is the ratio of the Trade (in US$) of Ghana in 2001 to that in 2006?
Offer a terse response. 0.41. What is the ratio of the Trade (in US$) of Senegal in 2001 to that in 2006?
Your answer should be compact. 0.46. What is the ratio of the Trade (in US$) in Europe(developing only) in 2001 to that in 2007?
Keep it short and to the point. 0.26. What is the ratio of the Trade (in US$) in Congo (Republic) in 2001 to that in 2007?
Your answer should be very brief. 0.33. What is the ratio of the Trade (in US$) in Ghana in 2001 to that in 2007?
Your answer should be very brief. 0.34. What is the ratio of the Trade (in US$) in Senegal in 2001 to that in 2007?
Provide a succinct answer. 0.34. What is the ratio of the Trade (in US$) of Europe(developing only) in 2002 to that in 2003?
Ensure brevity in your answer.  0.76. What is the ratio of the Trade (in US$) in Congo (Republic) in 2002 to that in 2003?
Provide a succinct answer. 0.61. What is the ratio of the Trade (in US$) in Ghana in 2002 to that in 2003?
Your answer should be compact. 0.78. What is the ratio of the Trade (in US$) of Senegal in 2002 to that in 2003?
Your answer should be very brief. 0.78. What is the ratio of the Trade (in US$) in Europe(developing only) in 2002 to that in 2004?
Offer a terse response. 0.56. What is the ratio of the Trade (in US$) in Congo (Republic) in 2002 to that in 2004?
Offer a terse response. 0.69. What is the ratio of the Trade (in US$) in Ghana in 2002 to that in 2004?
Your answer should be very brief. 0.63. What is the ratio of the Trade (in US$) in Senegal in 2002 to that in 2004?
Your response must be concise. 0.65. What is the ratio of the Trade (in US$) in Europe(developing only) in 2002 to that in 2005?
Your answer should be compact. 0.47. What is the ratio of the Trade (in US$) of Congo (Republic) in 2002 to that in 2005?
Provide a succinct answer. 0.49. What is the ratio of the Trade (in US$) in Ghana in 2002 to that in 2005?
Ensure brevity in your answer.  0.51. What is the ratio of the Trade (in US$) in Senegal in 2002 to that in 2005?
Give a very brief answer. 0.56. What is the ratio of the Trade (in US$) of Europe(developing only) in 2002 to that in 2006?
Your response must be concise. 0.39. What is the ratio of the Trade (in US$) in Congo (Republic) in 2002 to that in 2006?
Offer a very short reply. 0.32. What is the ratio of the Trade (in US$) of Ghana in 2002 to that in 2006?
Keep it short and to the point. 0.41. What is the ratio of the Trade (in US$) of Senegal in 2002 to that in 2006?
Your answer should be very brief. 0.52. What is the ratio of the Trade (in US$) in Europe(developing only) in 2002 to that in 2007?
Make the answer very short. 0.3. What is the ratio of the Trade (in US$) in Congo (Republic) in 2002 to that in 2007?
Your answer should be very brief. 0.36. What is the ratio of the Trade (in US$) of Ghana in 2002 to that in 2007?
Offer a very short reply. 0.33. What is the ratio of the Trade (in US$) in Senegal in 2002 to that in 2007?
Give a very brief answer. 0.38. What is the ratio of the Trade (in US$) in Europe(developing only) in 2003 to that in 2004?
Keep it short and to the point. 0.73. What is the ratio of the Trade (in US$) of Ghana in 2003 to that in 2004?
Offer a terse response. 0.81. What is the ratio of the Trade (in US$) in Senegal in 2003 to that in 2004?
Make the answer very short. 0.83. What is the ratio of the Trade (in US$) of Europe(developing only) in 2003 to that in 2005?
Ensure brevity in your answer.  0.62. What is the ratio of the Trade (in US$) of Congo (Republic) in 2003 to that in 2005?
Your answer should be very brief. 0.8. What is the ratio of the Trade (in US$) in Ghana in 2003 to that in 2005?
Offer a terse response. 0.65. What is the ratio of the Trade (in US$) of Senegal in 2003 to that in 2005?
Your answer should be very brief. 0.72. What is the ratio of the Trade (in US$) in Europe(developing only) in 2003 to that in 2006?
Ensure brevity in your answer.  0.5. What is the ratio of the Trade (in US$) in Congo (Republic) in 2003 to that in 2006?
Give a very brief answer. 0.52. What is the ratio of the Trade (in US$) in Ghana in 2003 to that in 2006?
Keep it short and to the point. 0.52. What is the ratio of the Trade (in US$) in Senegal in 2003 to that in 2006?
Provide a succinct answer. 0.66. What is the ratio of the Trade (in US$) in Europe(developing only) in 2003 to that in 2007?
Keep it short and to the point. 0.39. What is the ratio of the Trade (in US$) of Congo (Republic) in 2003 to that in 2007?
Make the answer very short. 0.59. What is the ratio of the Trade (in US$) of Ghana in 2003 to that in 2007?
Offer a terse response. 0.43. What is the ratio of the Trade (in US$) of Senegal in 2003 to that in 2007?
Ensure brevity in your answer.  0.49. What is the ratio of the Trade (in US$) in Europe(developing only) in 2004 to that in 2005?
Keep it short and to the point. 0.84. What is the ratio of the Trade (in US$) of Congo (Republic) in 2004 to that in 2005?
Ensure brevity in your answer.  0.71. What is the ratio of the Trade (in US$) in Ghana in 2004 to that in 2005?
Keep it short and to the point. 0.81. What is the ratio of the Trade (in US$) of Senegal in 2004 to that in 2005?
Keep it short and to the point. 0.86. What is the ratio of the Trade (in US$) of Europe(developing only) in 2004 to that in 2006?
Make the answer very short. 0.69. What is the ratio of the Trade (in US$) in Congo (Republic) in 2004 to that in 2006?
Ensure brevity in your answer.  0.47. What is the ratio of the Trade (in US$) of Ghana in 2004 to that in 2006?
Give a very brief answer. 0.65. What is the ratio of the Trade (in US$) of Senegal in 2004 to that in 2006?
Your answer should be compact. 0.79. What is the ratio of the Trade (in US$) in Europe(developing only) in 2004 to that in 2007?
Provide a succinct answer. 0.53. What is the ratio of the Trade (in US$) of Congo (Republic) in 2004 to that in 2007?
Provide a short and direct response. 0.53. What is the ratio of the Trade (in US$) in Ghana in 2004 to that in 2007?
Provide a succinct answer. 0.53. What is the ratio of the Trade (in US$) of Senegal in 2004 to that in 2007?
Give a very brief answer. 0.59. What is the ratio of the Trade (in US$) in Europe(developing only) in 2005 to that in 2006?
Your answer should be compact. 0.82. What is the ratio of the Trade (in US$) of Congo (Republic) in 2005 to that in 2006?
Your answer should be compact. 0.65. What is the ratio of the Trade (in US$) of Ghana in 2005 to that in 2006?
Your response must be concise. 0.8. What is the ratio of the Trade (in US$) of Senegal in 2005 to that in 2006?
Give a very brief answer. 0.92. What is the ratio of the Trade (in US$) of Europe(developing only) in 2005 to that in 2007?
Provide a succinct answer. 0.63. What is the ratio of the Trade (in US$) in Congo (Republic) in 2005 to that in 2007?
Keep it short and to the point. 0.74. What is the ratio of the Trade (in US$) in Ghana in 2005 to that in 2007?
Provide a short and direct response. 0.66. What is the ratio of the Trade (in US$) in Senegal in 2005 to that in 2007?
Make the answer very short. 0.68. What is the ratio of the Trade (in US$) of Europe(developing only) in 2006 to that in 2007?
Provide a succinct answer. 0.77. What is the ratio of the Trade (in US$) of Congo (Republic) in 2006 to that in 2007?
Your answer should be very brief. 1.13. What is the ratio of the Trade (in US$) of Ghana in 2006 to that in 2007?
Provide a succinct answer. 0.82. What is the ratio of the Trade (in US$) of Senegal in 2006 to that in 2007?
Your response must be concise. 0.75. What is the difference between the highest and the second highest Trade (in US$) in Europe(developing only)?
Provide a succinct answer. 1.21e+11. What is the difference between the highest and the second highest Trade (in US$) of Congo (Republic)?
Make the answer very short. 5.80e+08. What is the difference between the highest and the second highest Trade (in US$) in Ghana?
Keep it short and to the point. 1.80e+09. What is the difference between the highest and the second highest Trade (in US$) of Senegal?
Provide a short and direct response. 1.37e+09. What is the difference between the highest and the lowest Trade (in US$) of Europe(developing only)?
Your answer should be very brief. 3.86e+11. What is the difference between the highest and the lowest Trade (in US$) of Congo (Republic)?
Give a very brief answer. 3.67e+09. What is the difference between the highest and the lowest Trade (in US$) of Ghana?
Keep it short and to the point. 6.76e+09. What is the difference between the highest and the lowest Trade (in US$) in Senegal?
Give a very brief answer. 3.66e+09. 